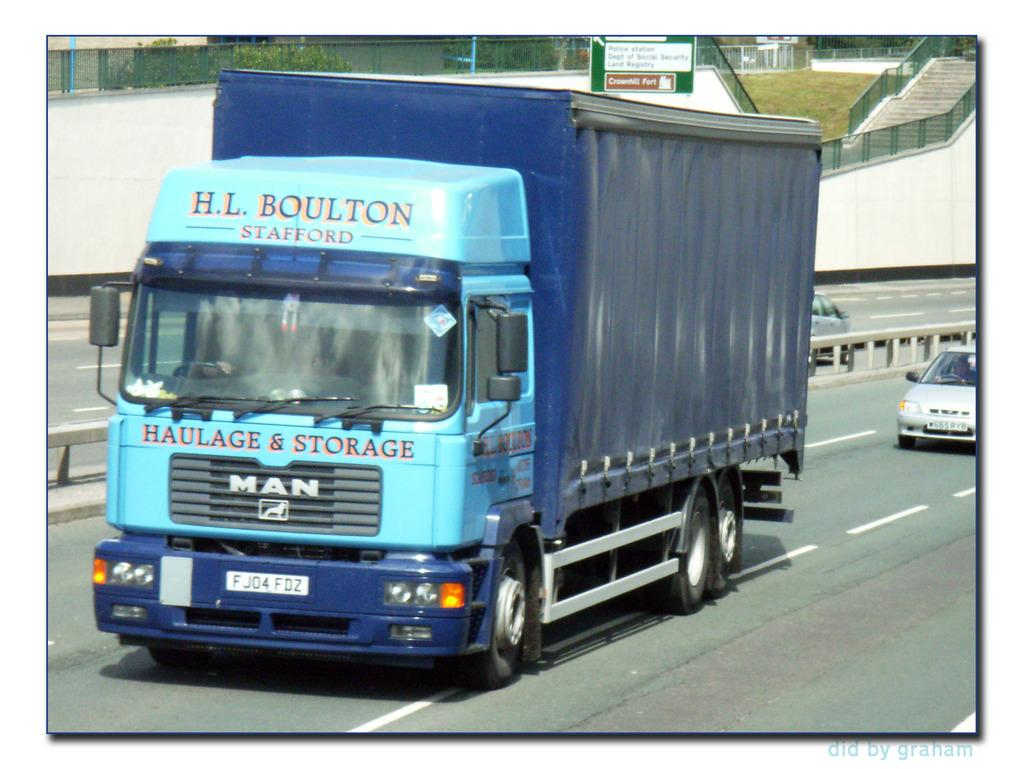What type of vehicle is the main subject in the image? There is a truck in the image. What else can be seen on the road in the image? There are cars on the road in the image. What is visible in the background of the image? There is a hoarding and trees in the background of the image. What type of jar is being used to surprise the apparatus in the image? There is no jar, surprise, or apparatus present in the image. 